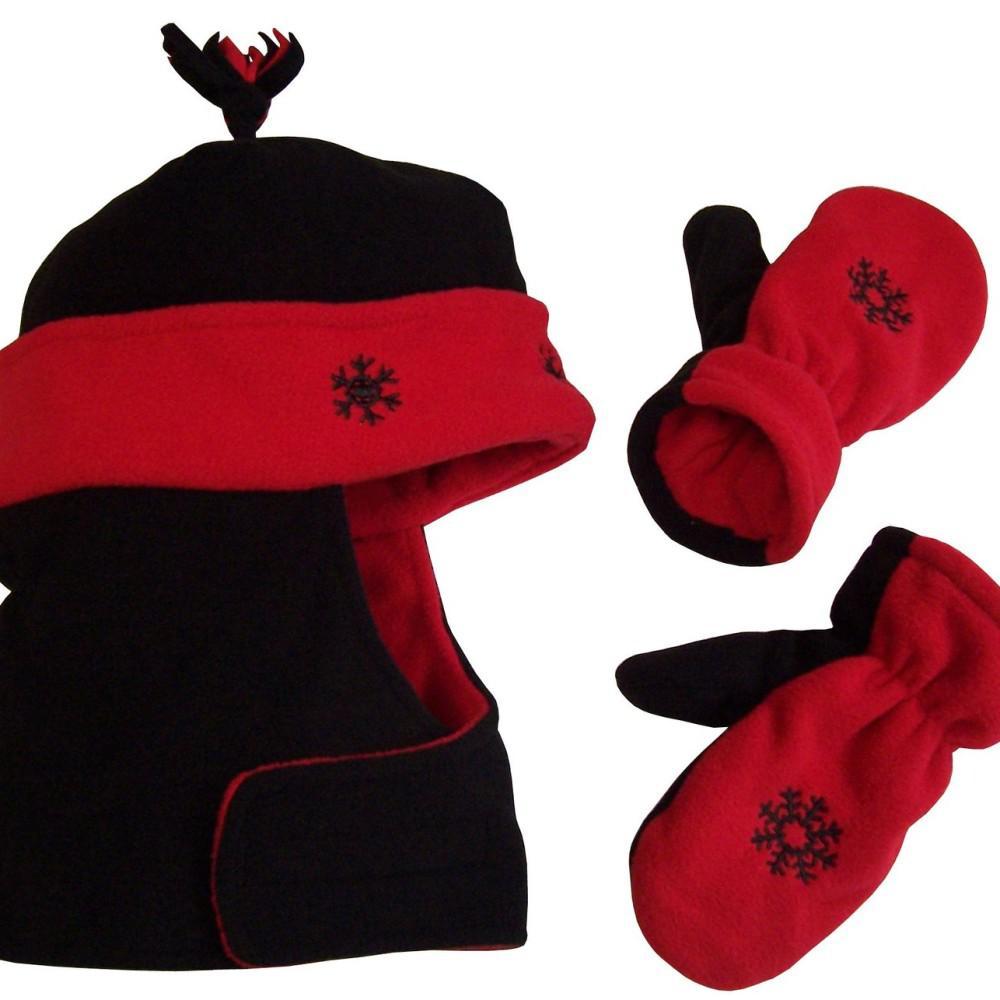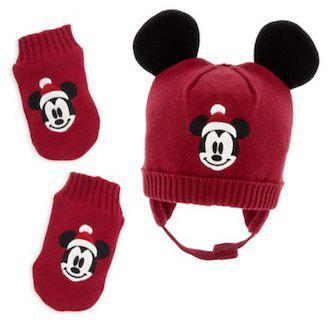The first image is the image on the left, the second image is the image on the right. Analyze the images presented: Is the assertion "The left image includes mittens next to a cap with black ears and pink polka dotted bow, and the right image shows mittens by a cap with black ears and white dots on red." valid? Answer yes or no. No. The first image is the image on the left, the second image is the image on the right. For the images shown, is this caption "Both images in the pair show a winter hat and mittens which are Micky Mouse or Minnie Mouse themed." true? Answer yes or no. No. 